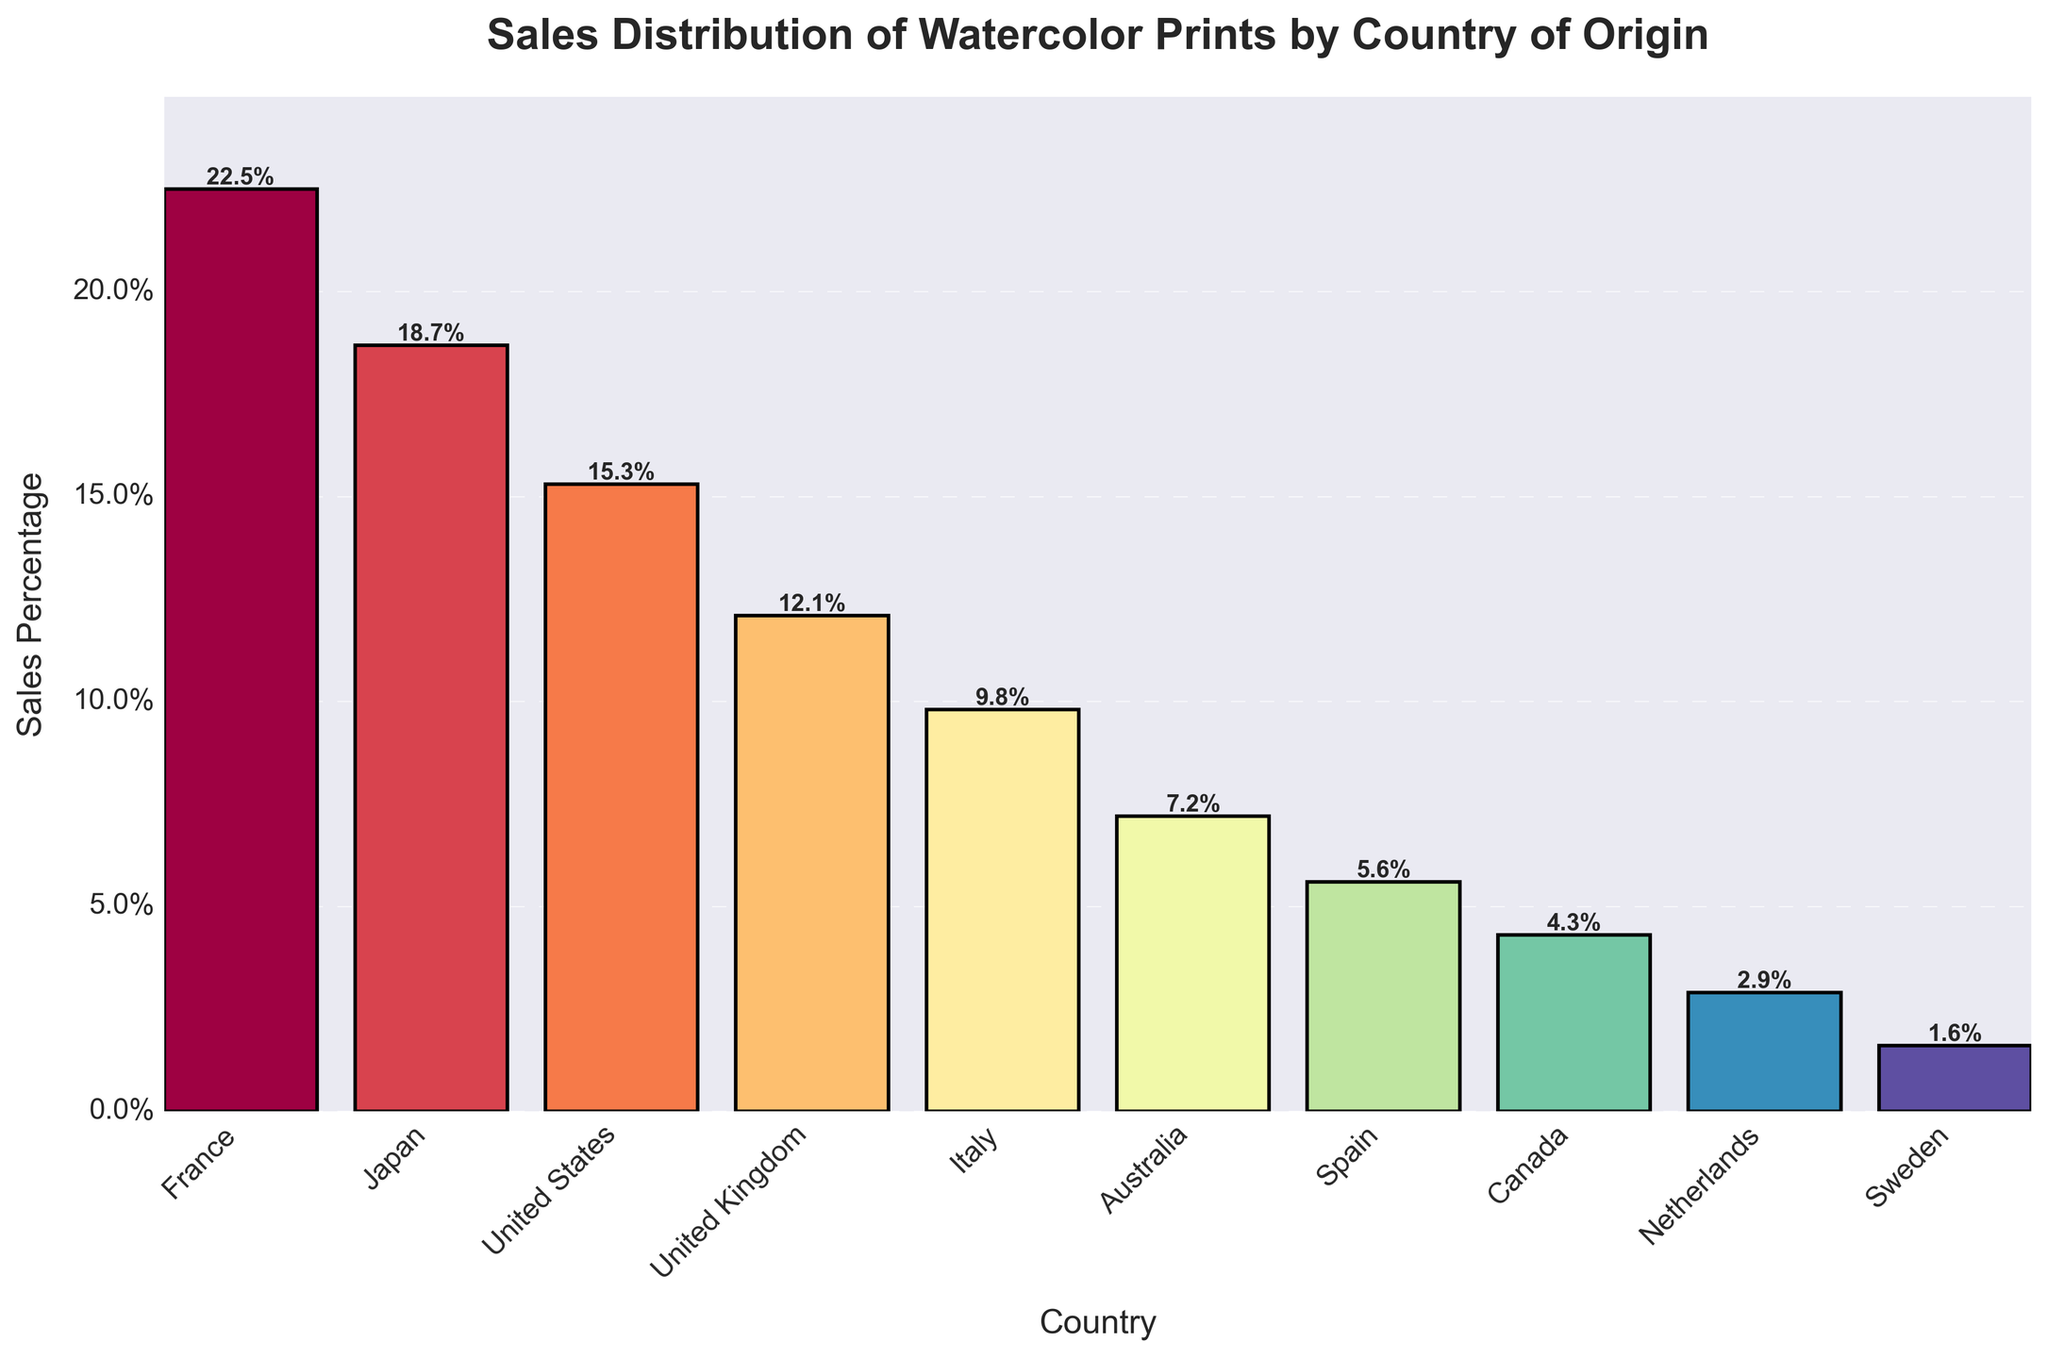Which country has the highest sales percentage of watercolor prints? The tallest bar in the bar chart corresponds to France, which has the highest sales percentage.
Answer: France Which country has the lowest sales percentage, and what is it? The shortest bar in the bar chart corresponds to Sweden, which has the lowest sales percentage.
Answer: Sweden, 1.6% What is the combined sales percentage of watercolor prints from the United States and the United Kingdom? The sales percentage for the United States is 15.3%, and for the United Kingdom, it is 12.1%. Summing these gives: 15.3% + 12.1% = 27.4%
Answer: 27.4% Is Japan's sales percentage higher than Italy's? The bar for Japan is taller than the bar for Italy, indicating that Japan's sales percentage is higher. Japan has 18.7% compared to Italy's 9.8%.
Answer: Yes What's the difference in sales percentage between France and Australia? France's sales percentage is 22.5%, and Australia's is 7.2%. Subtracting these gives: 22.5% - 7.2% = 15.3%
Answer: 15.3% Which three countries have the closest sales percentages? The sales percentages of Italy, Australia, and Spain are 9.8%, 7.2%, and 5.6%, respectively. The differences between these are smaller compared to differences among other countries.
Answer: Italy, Australia, Spain What percentage of the sales does Canada contribute, and how does it compare to the Netherlands? Canada's sales percentage is 4.3%, and the Netherlands' is 2.9%. Canada contributes more as 4.3% > 2.9%.
Answer: Canada, 4.3%, more How much more is the sales percentage of France compared to Canada? France's sales percentage is 22.5%, and Canada's is 4.3%. The difference is 22.5% - 4.3% = 18.2%.
Answer: 18.2% Which country has a sales percentage just above Spain? The sales percentage just above Spain's 5.6% is Australia's 7.2%.
Answer: Australia 